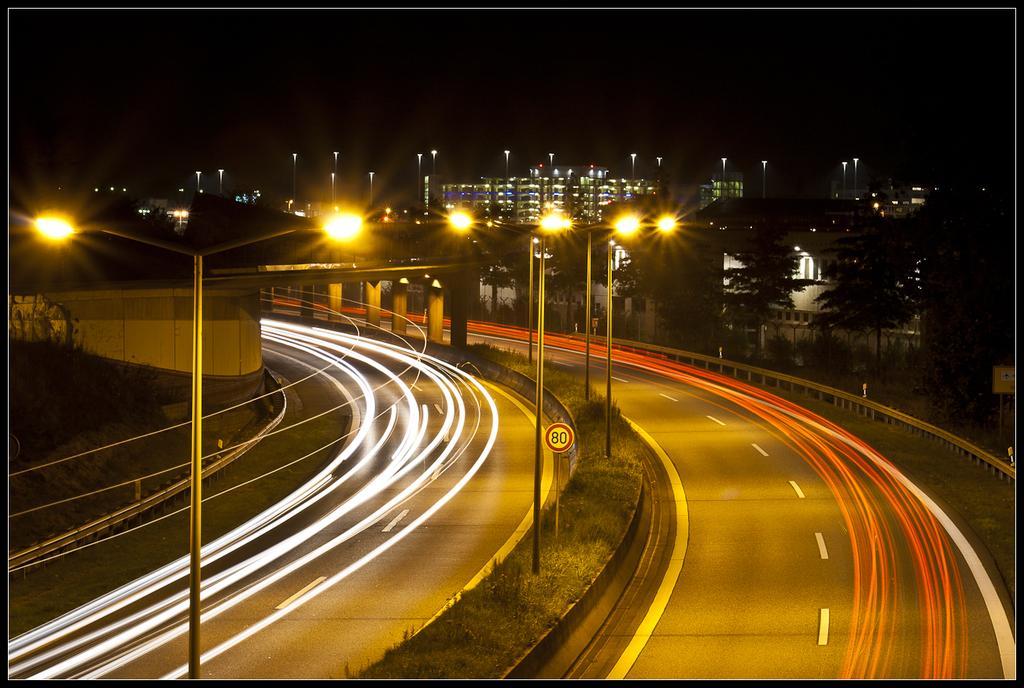Could you give a brief overview of what you see in this image? This is an image clicked in the dark. At the bottom there are two roads. In the middle of these roads there are many light poles. On the right and left side of the image I can see the railings. On the left side there is a bridge. In the background there are many buildings and trees. 